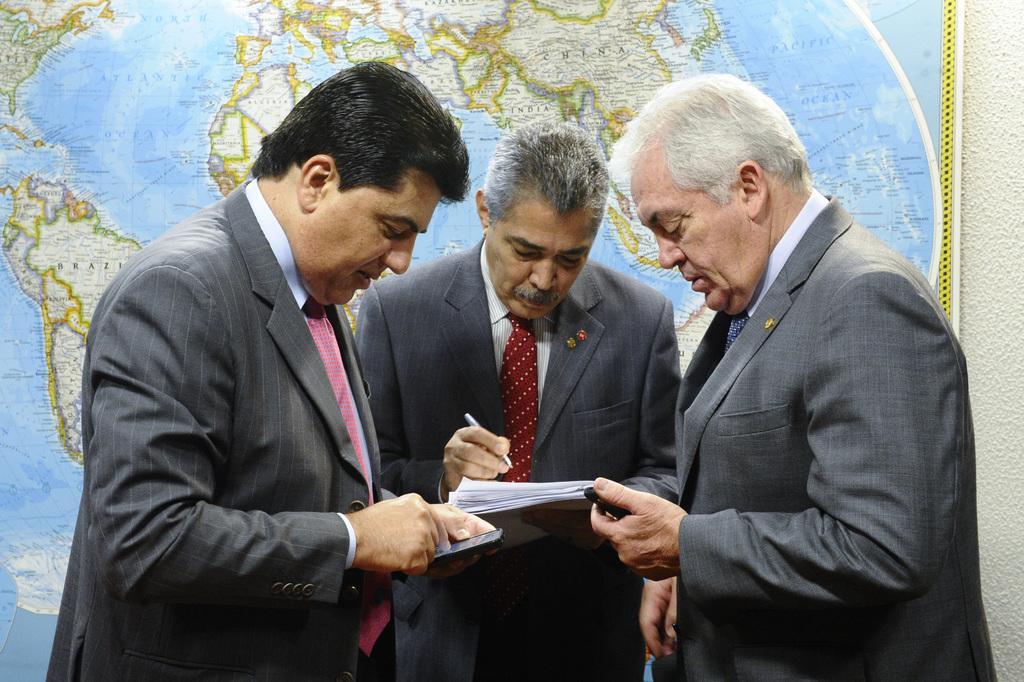How would you summarize this image in a sentence or two? In the center of the image there are persons standing on the floor. In the background there is a map. 